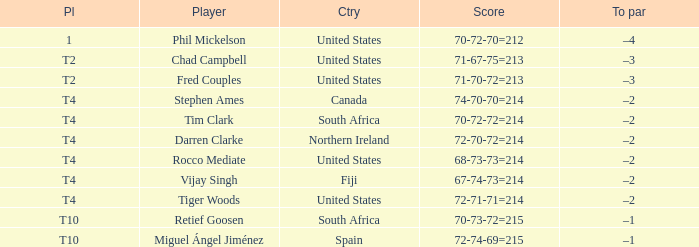What place was the scorer of 67-74-73=214? T4. 